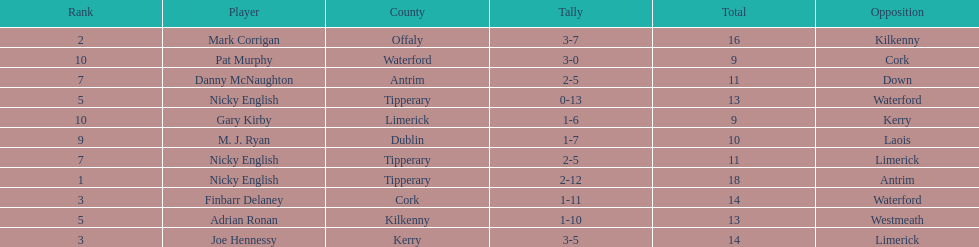What is the least total on the list? 9. 